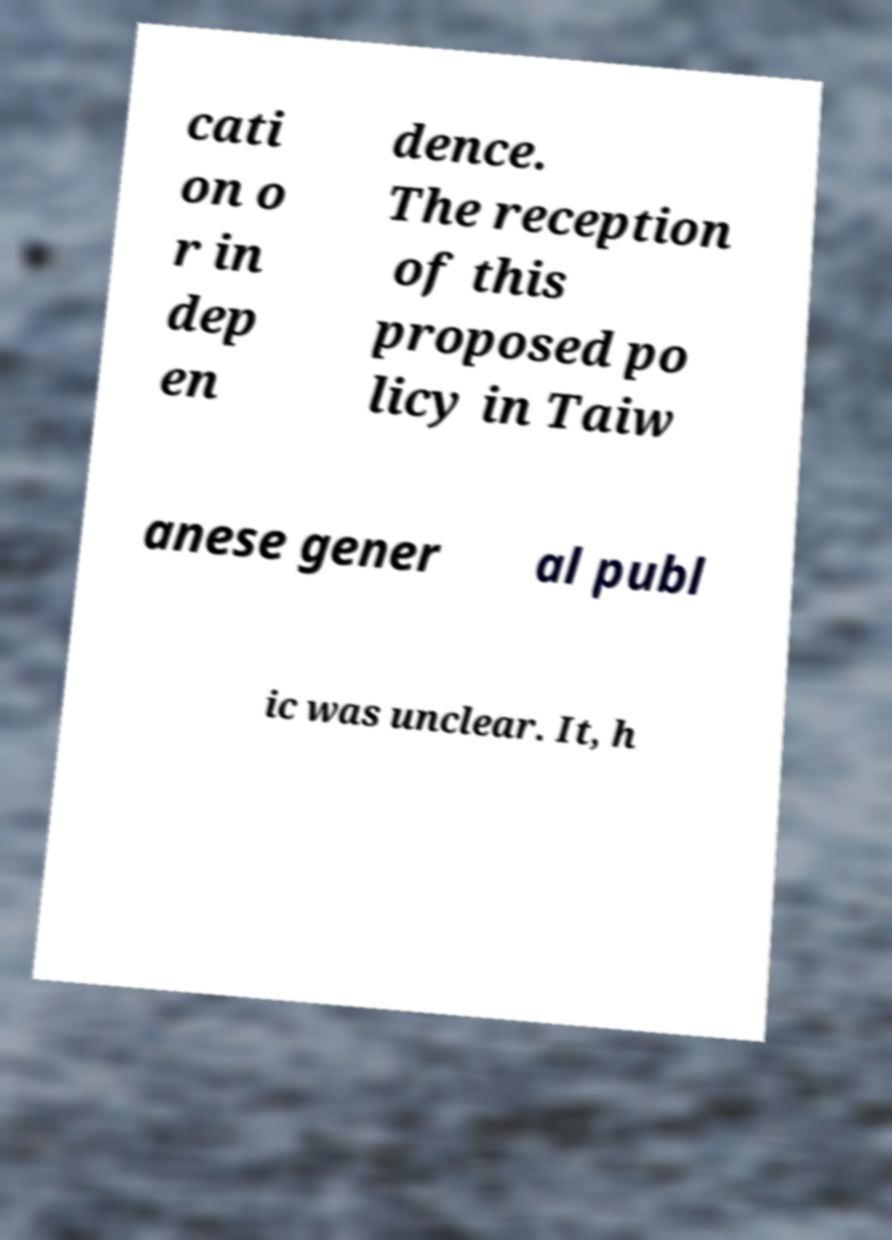Could you extract and type out the text from this image? cati on o r in dep en dence. The reception of this proposed po licy in Taiw anese gener al publ ic was unclear. It, h 